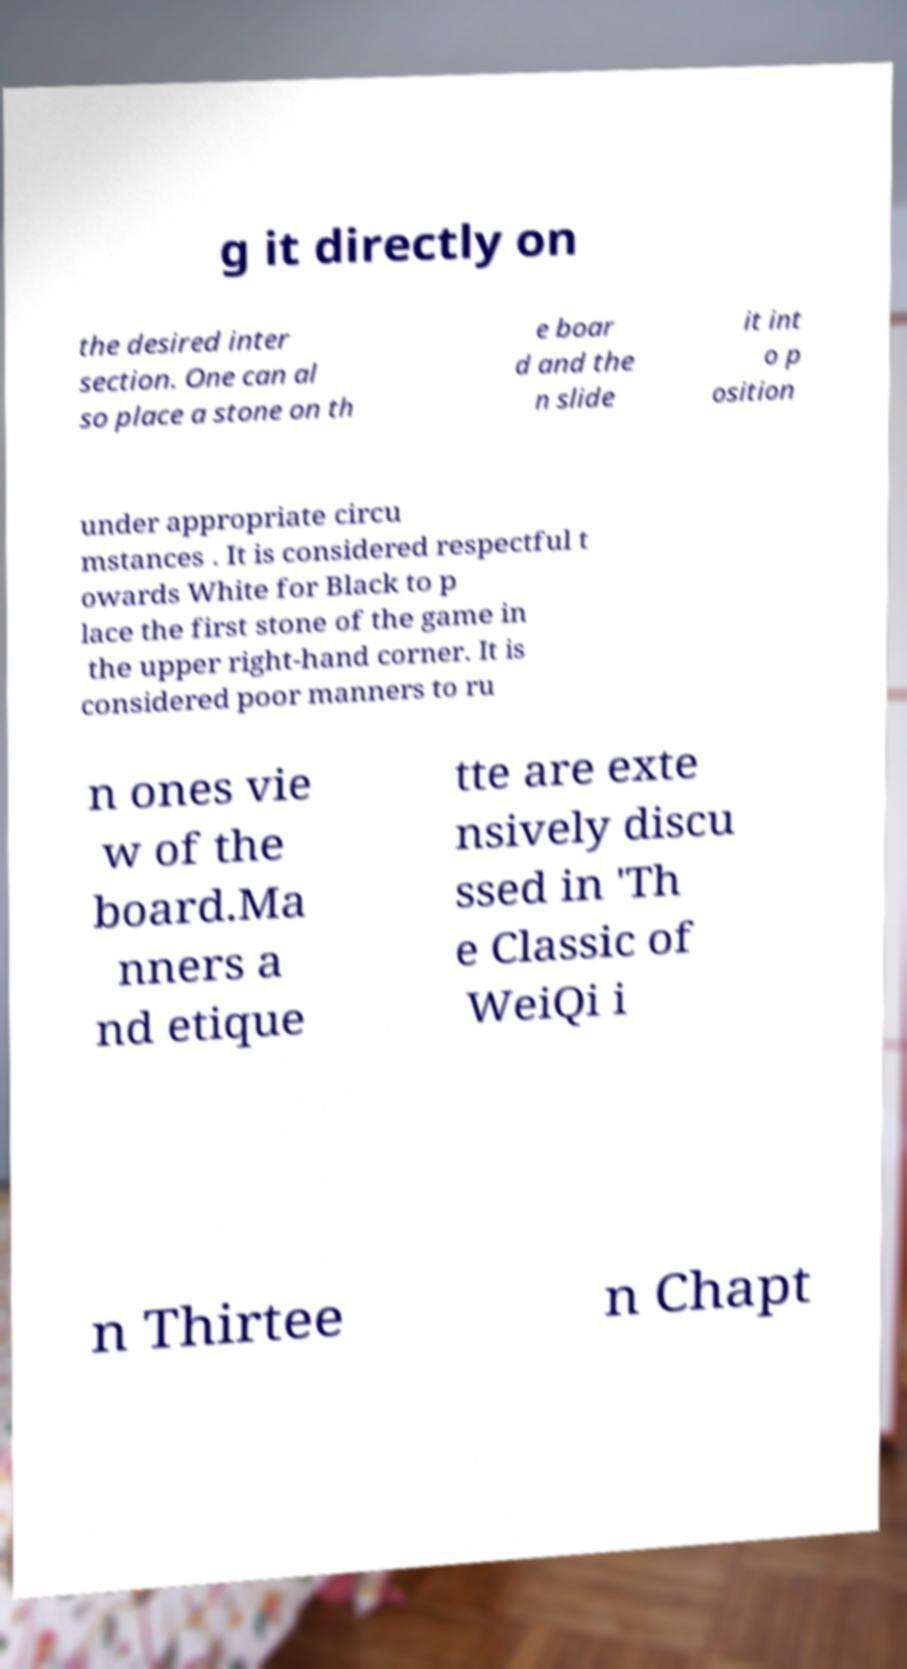What messages or text are displayed in this image? I need them in a readable, typed format. g it directly on the desired inter section. One can al so place a stone on th e boar d and the n slide it int o p osition under appropriate circu mstances . It is considered respectful t owards White for Black to p lace the first stone of the game in the upper right-hand corner. It is considered poor manners to ru n ones vie w of the board.Ma nners a nd etique tte are exte nsively discu ssed in 'Th e Classic of WeiQi i n Thirtee n Chapt 